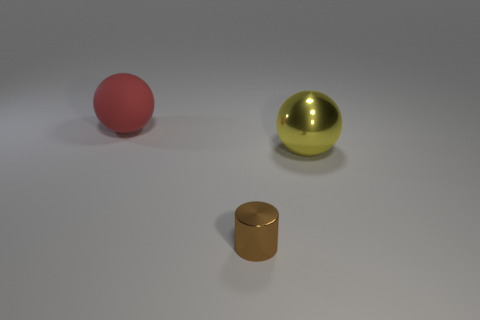Is there any other thing that is the same size as the red object?
Offer a terse response. Yes. There is another thing that is made of the same material as the brown object; what is its shape?
Make the answer very short. Sphere. Does the brown thing have the same shape as the big object that is in front of the red rubber sphere?
Offer a terse response. No. What is the brown cylinder made of?
Give a very brief answer. Metal. The large object that is behind the large ball that is right of the object behind the large yellow metal sphere is what color?
Your response must be concise. Red. What is the material of the big yellow thing that is the same shape as the red rubber thing?
Give a very brief answer. Metal. What number of red spheres have the same size as the brown metallic cylinder?
Your answer should be compact. 0. What number of red balls are there?
Your response must be concise. 1. Does the large yellow thing have the same material as the big sphere that is left of the yellow metal thing?
Make the answer very short. No. What number of brown objects are big matte things or tiny shiny cylinders?
Make the answer very short. 1. 